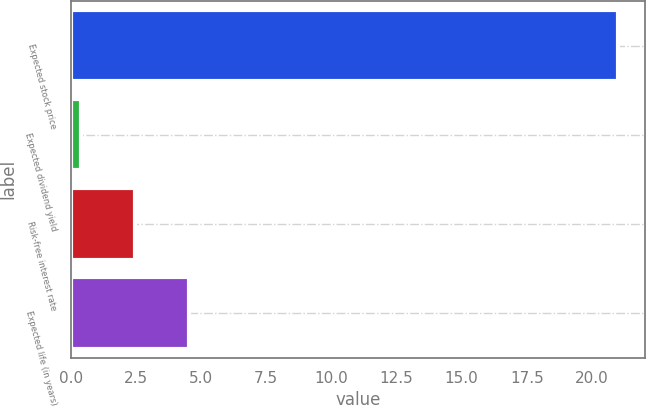Convert chart. <chart><loc_0><loc_0><loc_500><loc_500><bar_chart><fcel>Expected stock price<fcel>Expected dividend yield<fcel>Risk-free interest rate<fcel>Expected life (in years)<nl><fcel>21<fcel>0.4<fcel>2.46<fcel>4.52<nl></chart> 